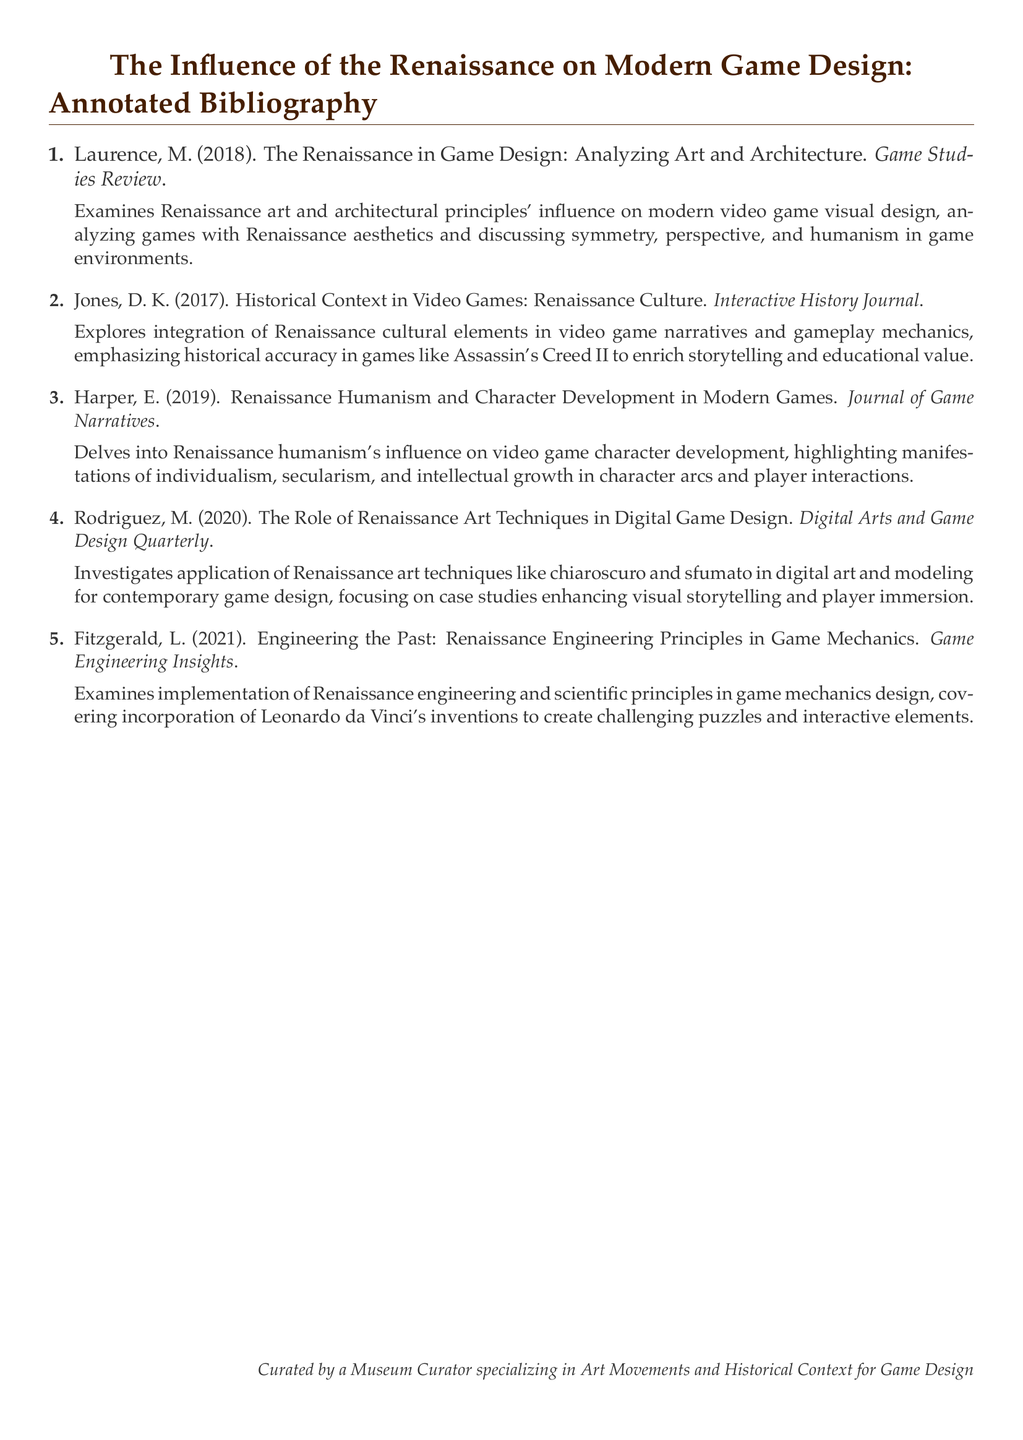What is the first entry in the bibliography? The first entry is titled "The Renaissance in Game Design: Analyzing Art and Architecture" by Laurence, M.
Answer: The Renaissance in Game Design: Analyzing Art and Architecture Who authored the second entry? The second entry is authored by D. K. Jones.
Answer: D. K. Jones How many entries are included in the bibliography? There are five entries listed in the document.
Answer: Five What year was the article "Renaissance Humanism and Character Development in Modern Games" published? It was published in 2019.
Answer: 2019 Which entry discusses the influence of Renaissance engineering principles? The entry by L. Fitzgerald covers this topic.
Answer: L. Fitzgerald What is the main focus of the article by M. Rodriguez? It focuses on the application of Renaissance art techniques in digital game design.
Answer: Application of Renaissance art techniques in digital game design Which journal published the paper by E. Harper? It was published in the Journal of Game Narratives.
Answer: Journal of Game Narratives What thematic element is explored in the second entry? The thematic element explored is Renaissance culture in video games.
Answer: Renaissance culture in video games What type of growth is highlighted in E. Harper's article concerning character development? Intellectual growth is highlighted in the article.
Answer: Intellectual growth 